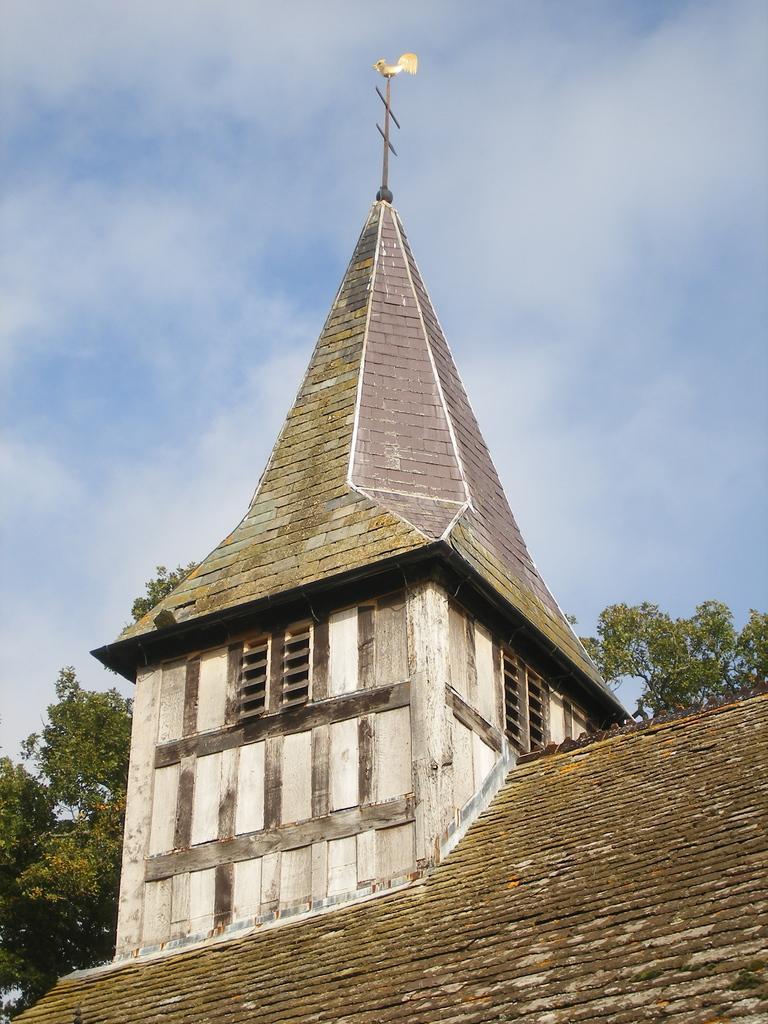Please provide a concise description of this image. Completely an outdoor picture. This is a house with roof top. This house is with window. Trees are in green color. Sky is cloudy, it is in blue and white color. 